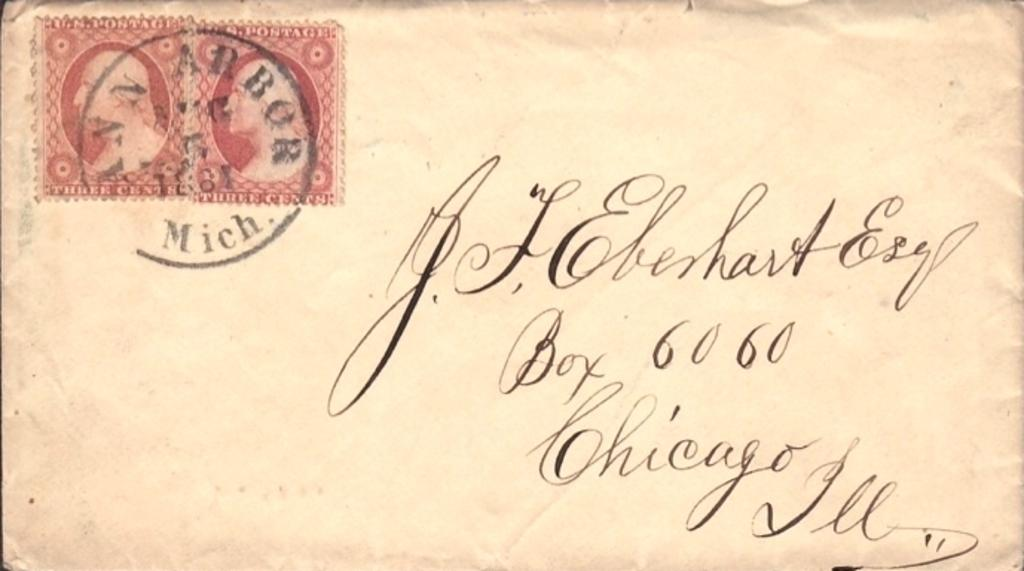<image>
Summarize the visual content of the image. A letter that is addressed to J.F Ebenhart Esq. 